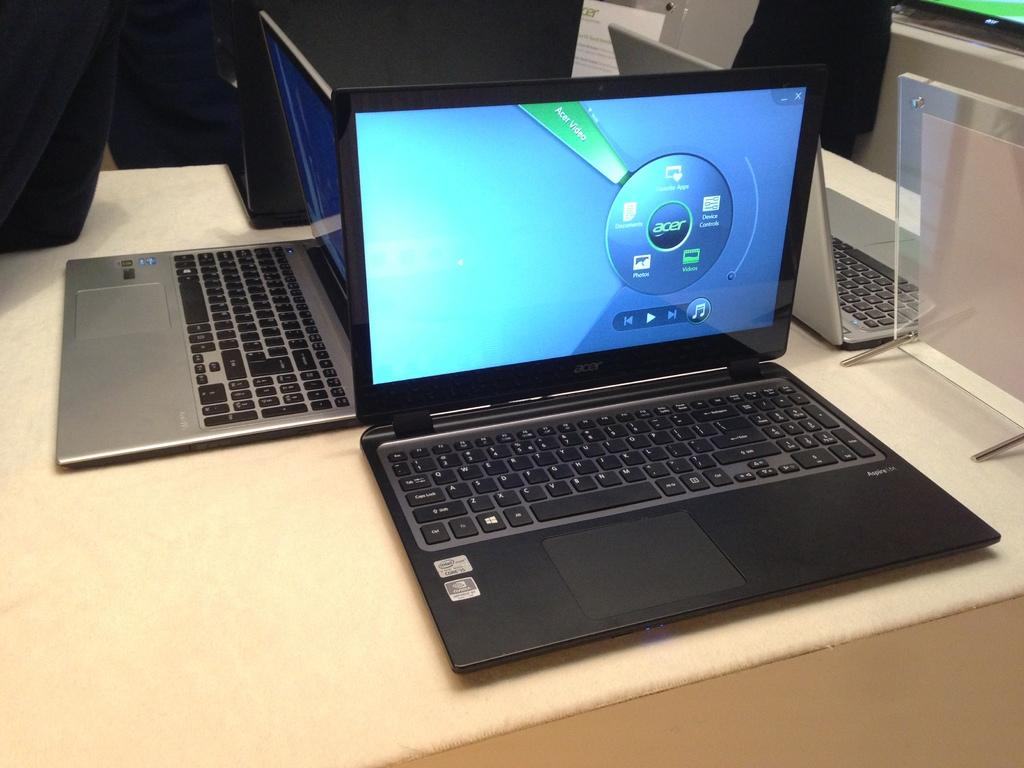Provide a one-sentence caption for the provided image. A black laptop with screen that displays an Acer brand. 